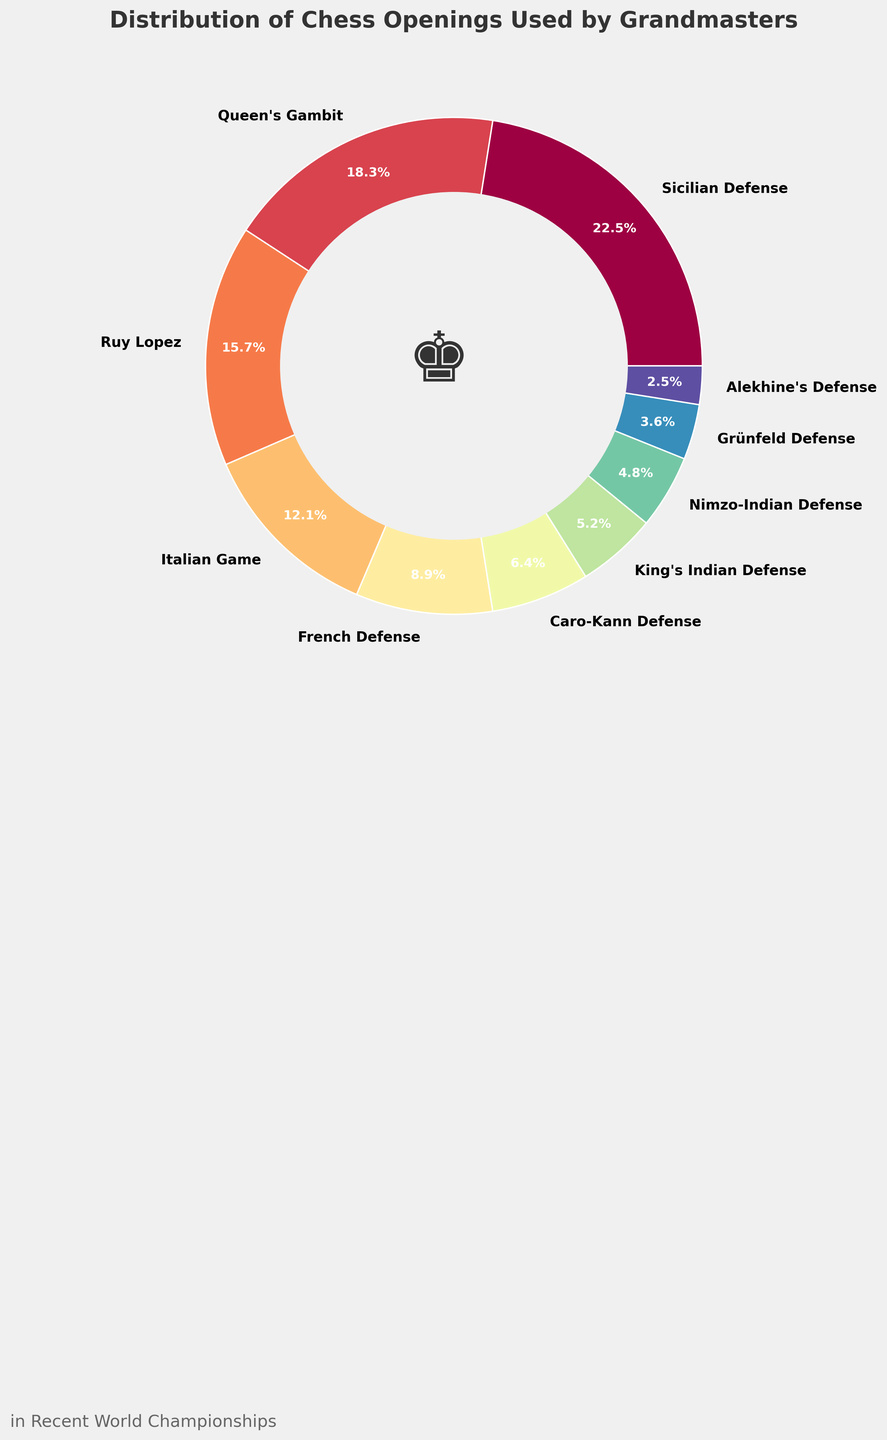what is the total percentage of openings starting with 'Indian Defense'? Combine the percentages of King's Indian Defense and Nimzo-Indian Defense. So, 5.2% + 4.8% = 10%.
Answer: 10% Which opening is more popular, Caro-Kann Defense or French Defense? Compare the percentages of each opening. Caro-Kann Defense is 6.4%, and French Defense is 8.9%. Since 8.9% is greater than 6.4%, the French Defense is more popular.
Answer: French Defense What percentage of grandmasters prefer either the Sicilian Defense or the Queen's Gambit? Add the percentages of the Sicilian Defense and the Queen's Gambit. So, 22.5% + 18.3% = 40.8%.
Answer: 40.8% Which two openings make up less than a combined 10% usage among grandmasters? Identify the openings that together make less than 10%. Alekhine's Defense (2.5%) and Grünfeld Defense (3.6%) add up to 2.5% + 3.6% = 6.1%, which is less than 10%.
Answer: Alekhine's Defense and Grünfeld Defense Which opening has the highest usage percentage? Find the opening with the highest percentage. The Sicilian Defense has 22.5%, which is the highest.
Answer: Sicilian Defense How does the use of the Ruy Lopez compare to the Italian Game? Look at the percentages of both openings. Ruy Lopez is 15.7%, and the Italian Game is 12.1%. Since 15.7% is greater than 12.1%, the Ruy Lopez is used more.
Answer: Ruy Lopez What is the cumulative percentage of the three least-used openings? Sum up the percentages of the least-used openings. Alekhine's Defense (2.5%), Grünfeld Defense (3.6%), and Nimzo-Indian Defense (4.8%). So, 2.5% + 3.6% + 4.8% = 10.9%.
Answer: 10.9% Which opening combination accounts for around 50% of the usage? Identify the combination almost approaching 50%. Sicilian Defense (22.5%) and Queen's Gambit (18.3%) add up to 22.5% + 18.3% = 40.8%. Including Ruy Lopez (15.7%) sums to 56.5%, which is over 50%. Thus, Sicilian Defense and Queen's Gambit nearly account for 50%.
Answer: Sicilian Defense and Queen's Gambit 